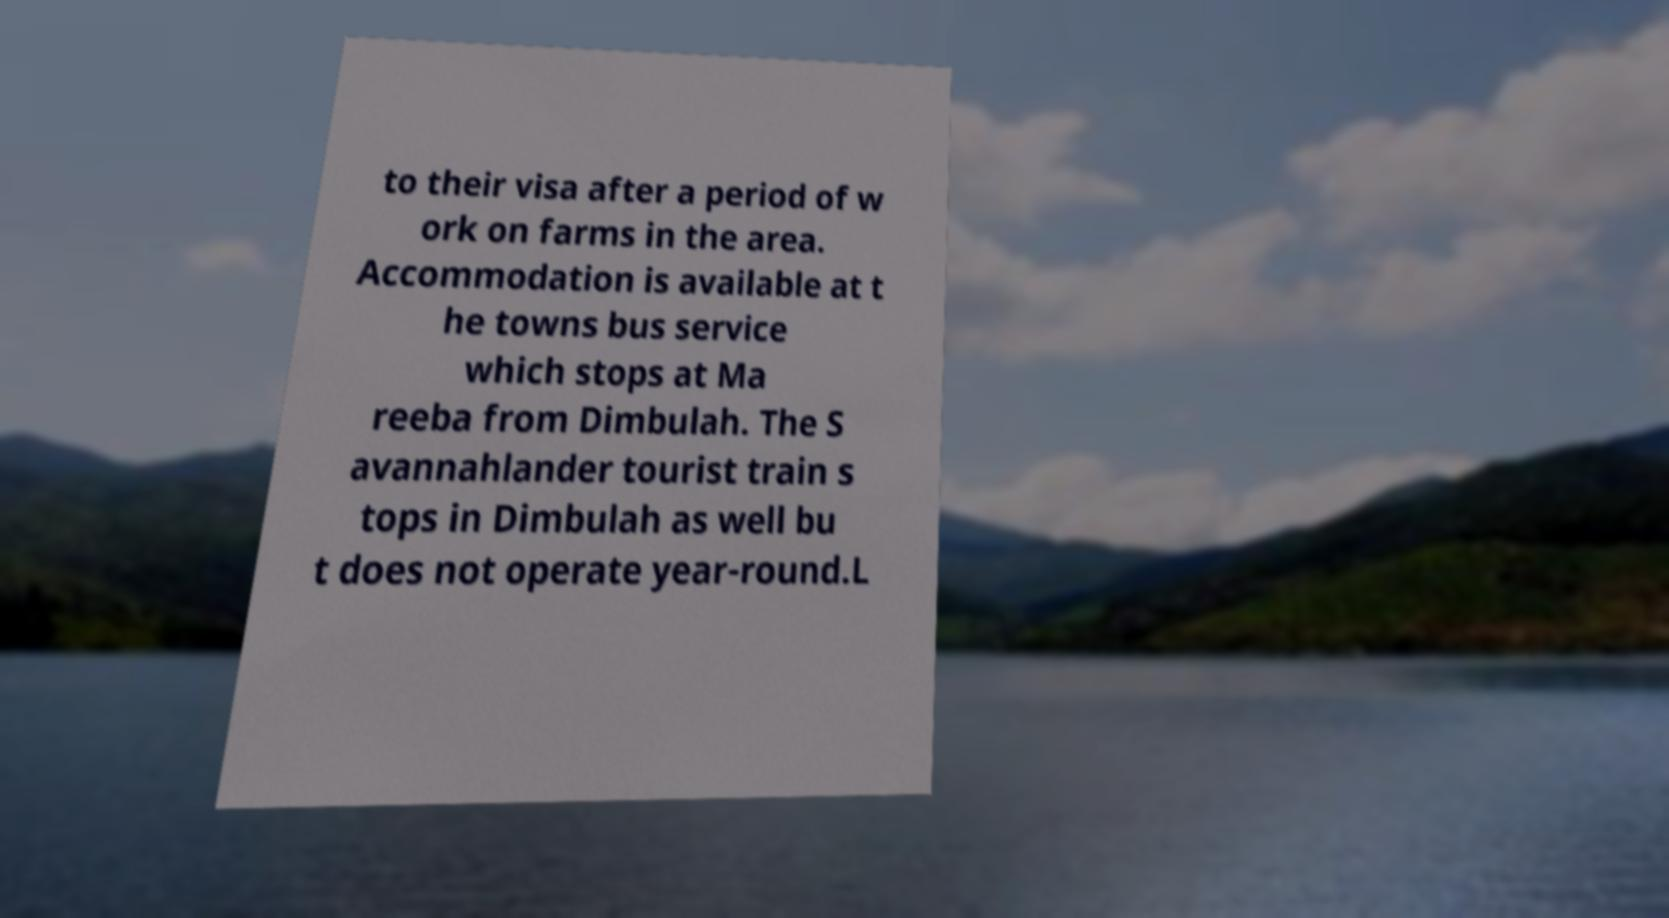Can you accurately transcribe the text from the provided image for me? to their visa after a period of w ork on farms in the area. Accommodation is available at t he towns bus service which stops at Ma reeba from Dimbulah. The S avannahlander tourist train s tops in Dimbulah as well bu t does not operate year-round.L 